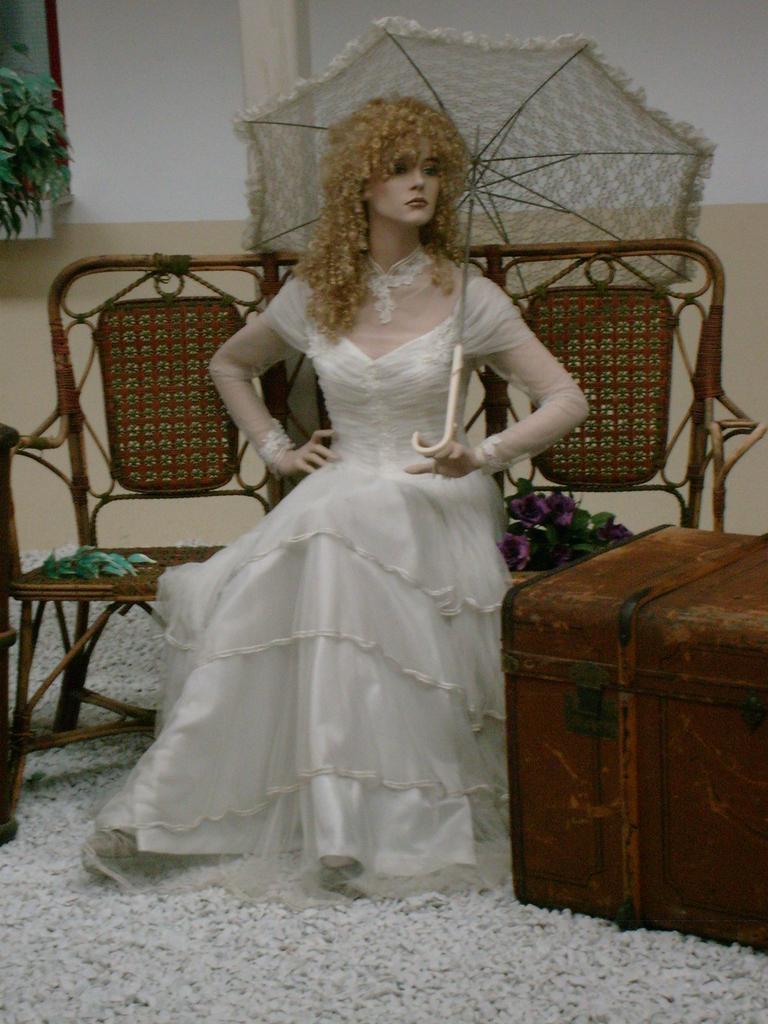Can you describe this image briefly? In this image i can see a woman in a white dress and brown hair is sitting on the bench and holding an umbrella. I can see the floor mat and a trunk box. In the background I can see the wall, a pillar and a tree. 